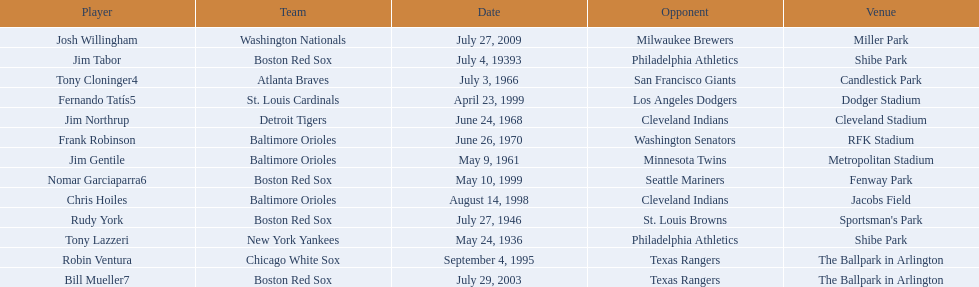Who were all the teams? New York Yankees, Boston Red Sox, Boston Red Sox, Baltimore Orioles, Atlanta Braves, Detroit Tigers, Baltimore Orioles, Chicago White Sox, Baltimore Orioles, St. Louis Cardinals, Boston Red Sox, Boston Red Sox, Washington Nationals. What about opponents? Philadelphia Athletics, Philadelphia Athletics, St. Louis Browns, Minnesota Twins, San Francisco Giants, Cleveland Indians, Washington Senators, Texas Rangers, Cleveland Indians, Los Angeles Dodgers, Seattle Mariners, Texas Rangers, Milwaukee Brewers. And when did they play? May 24, 1936, July 4, 19393, July 27, 1946, May 9, 1961, July 3, 1966, June 24, 1968, June 26, 1970, September 4, 1995, August 14, 1998, April 23, 1999, May 10, 1999, July 29, 2003, July 27, 2009. Which team played the red sox on july 27, 1946	? St. Louis Browns. 